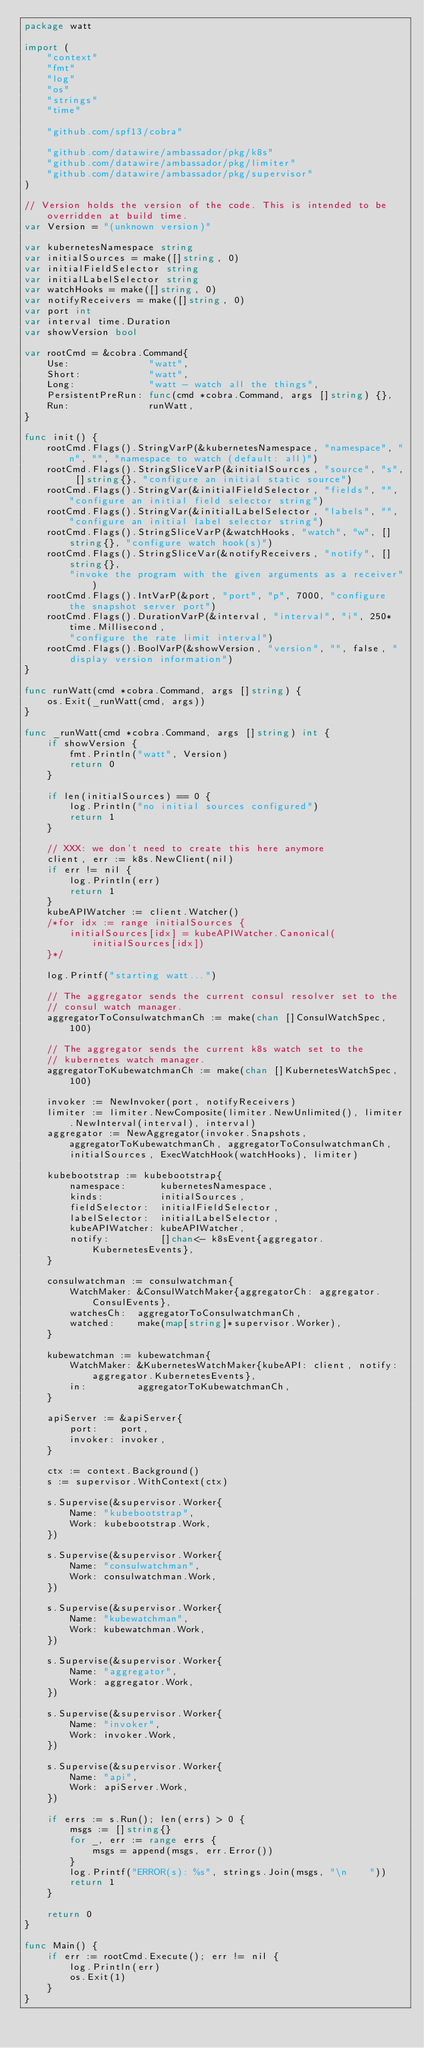<code> <loc_0><loc_0><loc_500><loc_500><_Go_>package watt

import (
	"context"
	"fmt"
	"log"
	"os"
	"strings"
	"time"

	"github.com/spf13/cobra"

	"github.com/datawire/ambassador/pkg/k8s"
	"github.com/datawire/ambassador/pkg/limiter"
	"github.com/datawire/ambassador/pkg/supervisor"
)

// Version holds the version of the code. This is intended to be overridden at build time.
var Version = "(unknown version)"

var kubernetesNamespace string
var initialSources = make([]string, 0)
var initialFieldSelector string
var initialLabelSelector string
var watchHooks = make([]string, 0)
var notifyReceivers = make([]string, 0)
var port int
var interval time.Duration
var showVersion bool

var rootCmd = &cobra.Command{
	Use:              "watt",
	Short:            "watt",
	Long:             "watt - watch all the things",
	PersistentPreRun: func(cmd *cobra.Command, args []string) {},
	Run:              runWatt,
}

func init() {
	rootCmd.Flags().StringVarP(&kubernetesNamespace, "namespace", "n", "", "namespace to watch (default: all)")
	rootCmd.Flags().StringSliceVarP(&initialSources, "source", "s", []string{}, "configure an initial static source")
	rootCmd.Flags().StringVar(&initialFieldSelector, "fields", "", "configure an initial field selector string")
	rootCmd.Flags().StringVar(&initialLabelSelector, "labels", "", "configure an initial label selector string")
	rootCmd.Flags().StringSliceVarP(&watchHooks, "watch", "w", []string{}, "configure watch hook(s)")
	rootCmd.Flags().StringSliceVar(&notifyReceivers, "notify", []string{},
		"invoke the program with the given arguments as a receiver")
	rootCmd.Flags().IntVarP(&port, "port", "p", 7000, "configure the snapshot server port")
	rootCmd.Flags().DurationVarP(&interval, "interval", "i", 250*time.Millisecond,
		"configure the rate limit interval")
	rootCmd.Flags().BoolVarP(&showVersion, "version", "", false, "display version information")
}

func runWatt(cmd *cobra.Command, args []string) {
	os.Exit(_runWatt(cmd, args))
}

func _runWatt(cmd *cobra.Command, args []string) int {
	if showVersion {
		fmt.Println("watt", Version)
		return 0
	}

	if len(initialSources) == 0 {
		log.Println("no initial sources configured")
		return 1
	}

	// XXX: we don't need to create this here anymore
	client, err := k8s.NewClient(nil)
	if err != nil {
		log.Println(err)
		return 1
	}
	kubeAPIWatcher := client.Watcher()
	/*for idx := range initialSources {
		initialSources[idx] = kubeAPIWatcher.Canonical(initialSources[idx])
	}*/

	log.Printf("starting watt...")

	// The aggregator sends the current consul resolver set to the
	// consul watch manager.
	aggregatorToConsulwatchmanCh := make(chan []ConsulWatchSpec, 100)

	// The aggregator sends the current k8s watch set to the
	// kubernetes watch manager.
	aggregatorToKubewatchmanCh := make(chan []KubernetesWatchSpec, 100)

	invoker := NewInvoker(port, notifyReceivers)
	limiter := limiter.NewComposite(limiter.NewUnlimited(), limiter.NewInterval(interval), interval)
	aggregator := NewAggregator(invoker.Snapshots, aggregatorToKubewatchmanCh, aggregatorToConsulwatchmanCh,
		initialSources, ExecWatchHook(watchHooks), limiter)

	kubebootstrap := kubebootstrap{
		namespace:      kubernetesNamespace,
		kinds:          initialSources,
		fieldSelector:  initialFieldSelector,
		labelSelector:  initialLabelSelector,
		kubeAPIWatcher: kubeAPIWatcher,
		notify:         []chan<- k8sEvent{aggregator.KubernetesEvents},
	}

	consulwatchman := consulwatchman{
		WatchMaker: &ConsulWatchMaker{aggregatorCh: aggregator.ConsulEvents},
		watchesCh:  aggregatorToConsulwatchmanCh,
		watched:    make(map[string]*supervisor.Worker),
	}

	kubewatchman := kubewatchman{
		WatchMaker: &KubernetesWatchMaker{kubeAPI: client, notify: aggregator.KubernetesEvents},
		in:         aggregatorToKubewatchmanCh,
	}

	apiServer := &apiServer{
		port:    port,
		invoker: invoker,
	}

	ctx := context.Background()
	s := supervisor.WithContext(ctx)

	s.Supervise(&supervisor.Worker{
		Name: "kubebootstrap",
		Work: kubebootstrap.Work,
	})

	s.Supervise(&supervisor.Worker{
		Name: "consulwatchman",
		Work: consulwatchman.Work,
	})

	s.Supervise(&supervisor.Worker{
		Name: "kubewatchman",
		Work: kubewatchman.Work,
	})

	s.Supervise(&supervisor.Worker{
		Name: "aggregator",
		Work: aggregator.Work,
	})

	s.Supervise(&supervisor.Worker{
		Name: "invoker",
		Work: invoker.Work,
	})

	s.Supervise(&supervisor.Worker{
		Name: "api",
		Work: apiServer.Work,
	})

	if errs := s.Run(); len(errs) > 0 {
		msgs := []string{}
		for _, err := range errs {
			msgs = append(msgs, err.Error())
		}
		log.Printf("ERROR(s): %s", strings.Join(msgs, "\n    "))
		return 1
	}

	return 0
}

func Main() {
	if err := rootCmd.Execute(); err != nil {
		log.Println(err)
		os.Exit(1)
	}
}
</code> 